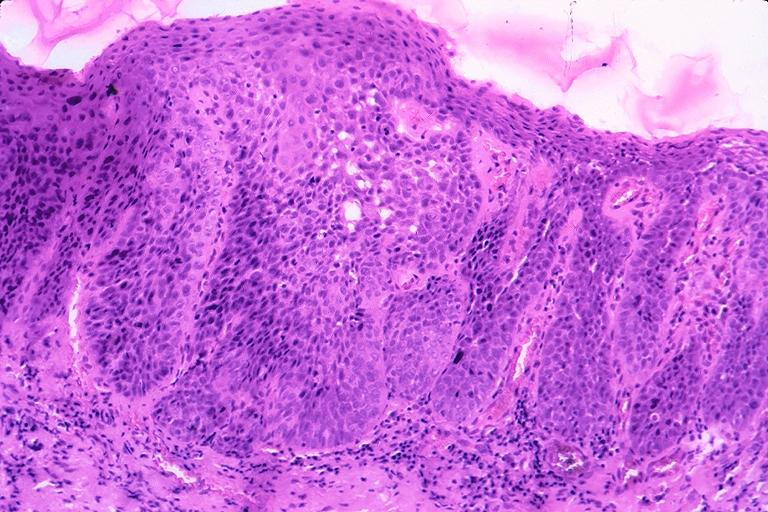what does this image show?
Answer the question using a single word or phrase. Squamous cell carcinoma 